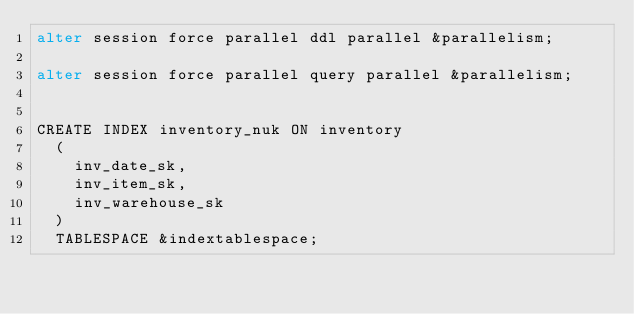<code> <loc_0><loc_0><loc_500><loc_500><_SQL_>alter session force parallel ddl parallel &parallelism;

alter session force parallel query parallel &parallelism;


CREATE INDEX inventory_nuk ON inventory
  (
    inv_date_sk,
    inv_item_sk,
    inv_warehouse_sk
  )
  TABLESPACE &indextablespace;

</code> 